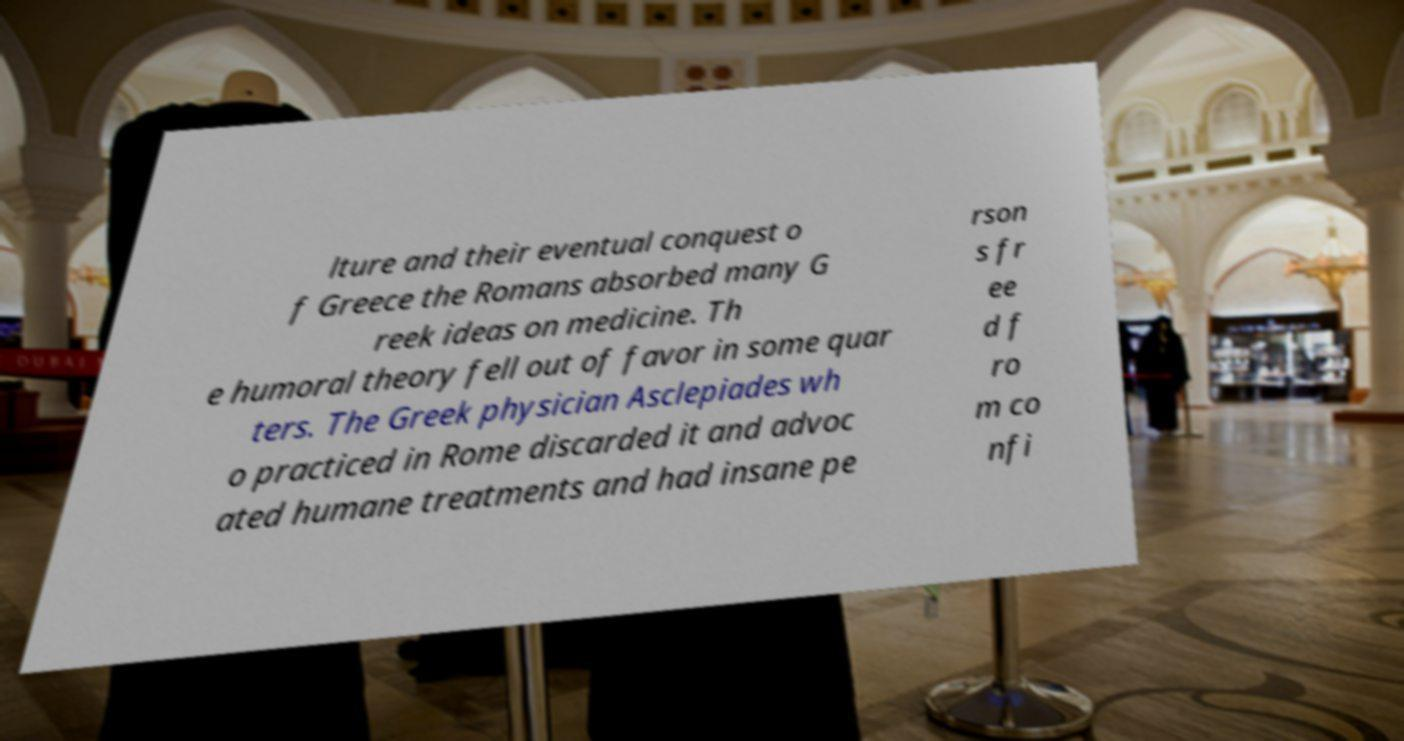For documentation purposes, I need the text within this image transcribed. Could you provide that? lture and their eventual conquest o f Greece the Romans absorbed many G reek ideas on medicine. Th e humoral theory fell out of favor in some quar ters. The Greek physician Asclepiades wh o practiced in Rome discarded it and advoc ated humane treatments and had insane pe rson s fr ee d f ro m co nfi 